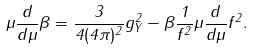Convert formula to latex. <formula><loc_0><loc_0><loc_500><loc_500>\mu \frac { d } { d \mu } \beta = \frac { 3 } { 4 ( 4 \pi ) ^ { 2 } } g _ { Y } ^ { 2 } - \beta \frac { 1 } { f ^ { 2 } } \mu \frac { d } { d \mu } f ^ { 2 } .</formula> 